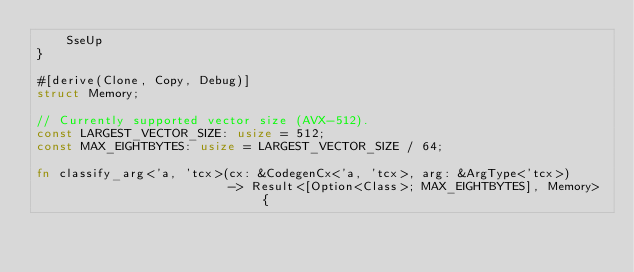Convert code to text. <code><loc_0><loc_0><loc_500><loc_500><_Rust_>    SseUp
}

#[derive(Clone, Copy, Debug)]
struct Memory;

// Currently supported vector size (AVX-512).
const LARGEST_VECTOR_SIZE: usize = 512;
const MAX_EIGHTBYTES: usize = LARGEST_VECTOR_SIZE / 64;

fn classify_arg<'a, 'tcx>(cx: &CodegenCx<'a, 'tcx>, arg: &ArgType<'tcx>)
                          -> Result<[Option<Class>; MAX_EIGHTBYTES], Memory> {</code> 